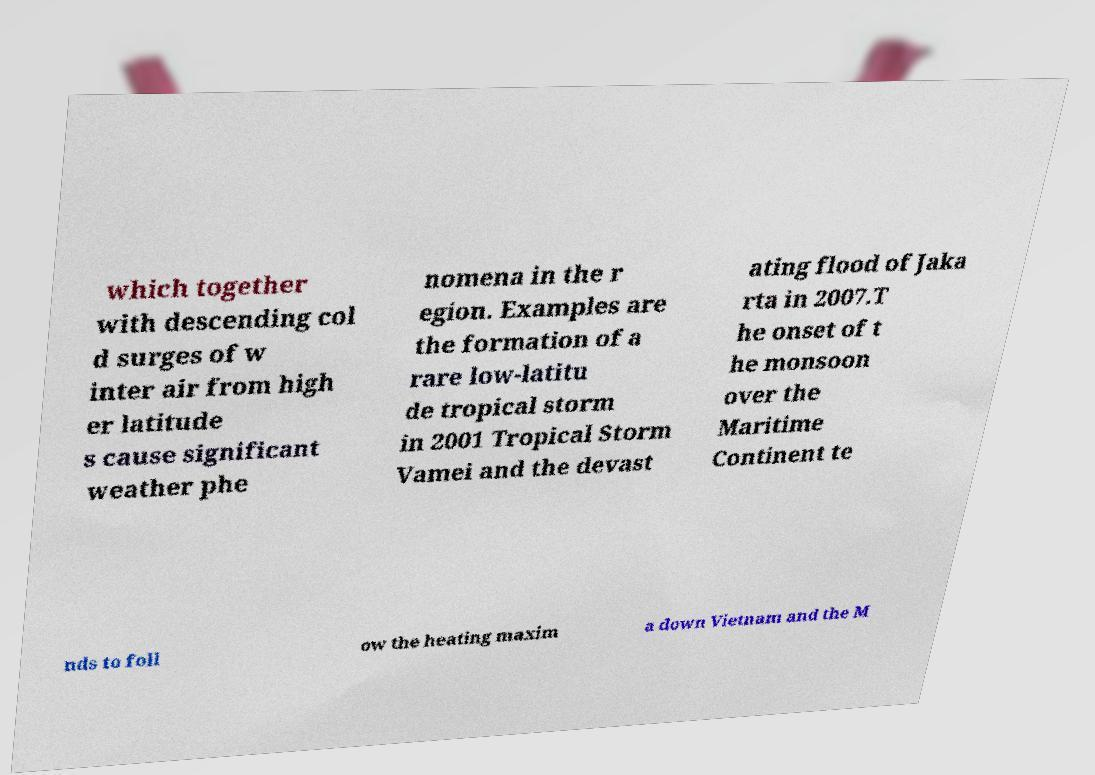There's text embedded in this image that I need extracted. Can you transcribe it verbatim? which together with descending col d surges of w inter air from high er latitude s cause significant weather phe nomena in the r egion. Examples are the formation of a rare low-latitu de tropical storm in 2001 Tropical Storm Vamei and the devast ating flood of Jaka rta in 2007.T he onset of t he monsoon over the Maritime Continent te nds to foll ow the heating maxim a down Vietnam and the M 